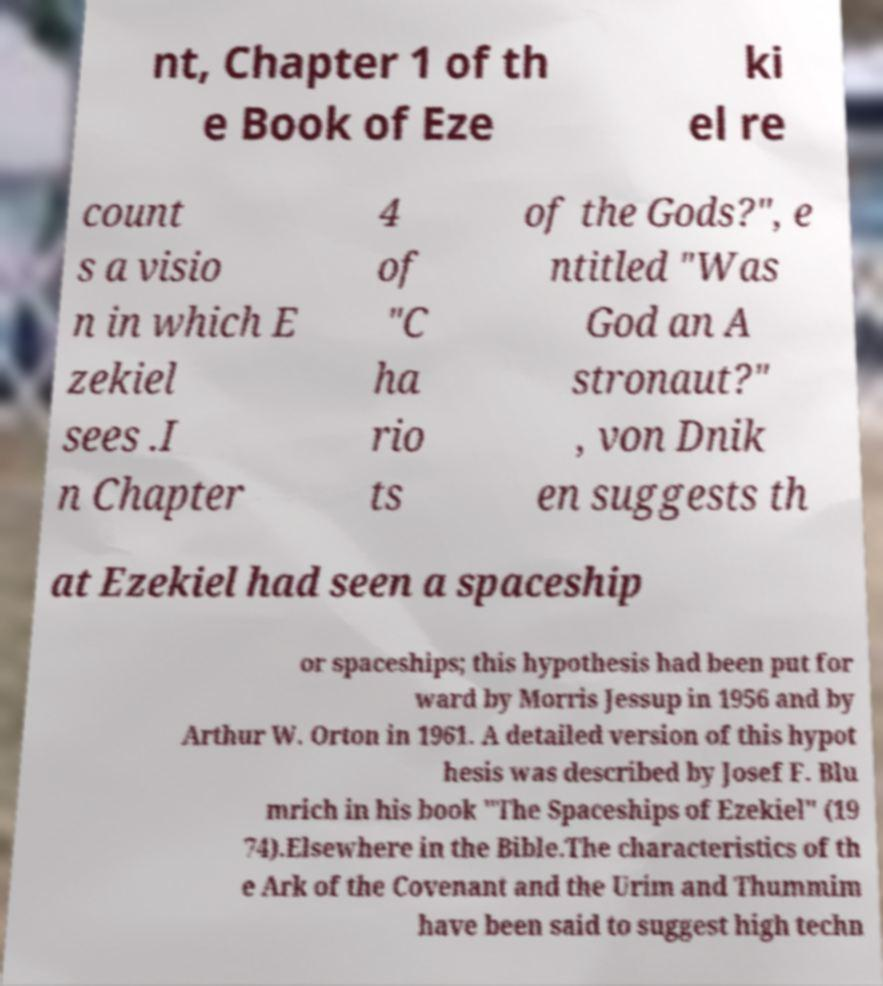Could you extract and type out the text from this image? nt, Chapter 1 of th e Book of Eze ki el re count s a visio n in which E zekiel sees .I n Chapter 4 of "C ha rio ts of the Gods?", e ntitled "Was God an A stronaut?" , von Dnik en suggests th at Ezekiel had seen a spaceship or spaceships; this hypothesis had been put for ward by Morris Jessup in 1956 and by Arthur W. Orton in 1961. A detailed version of this hypot hesis was described by Josef F. Blu mrich in his book "The Spaceships of Ezekiel" (19 74).Elsewhere in the Bible.The characteristics of th e Ark of the Covenant and the Urim and Thummim have been said to suggest high techn 